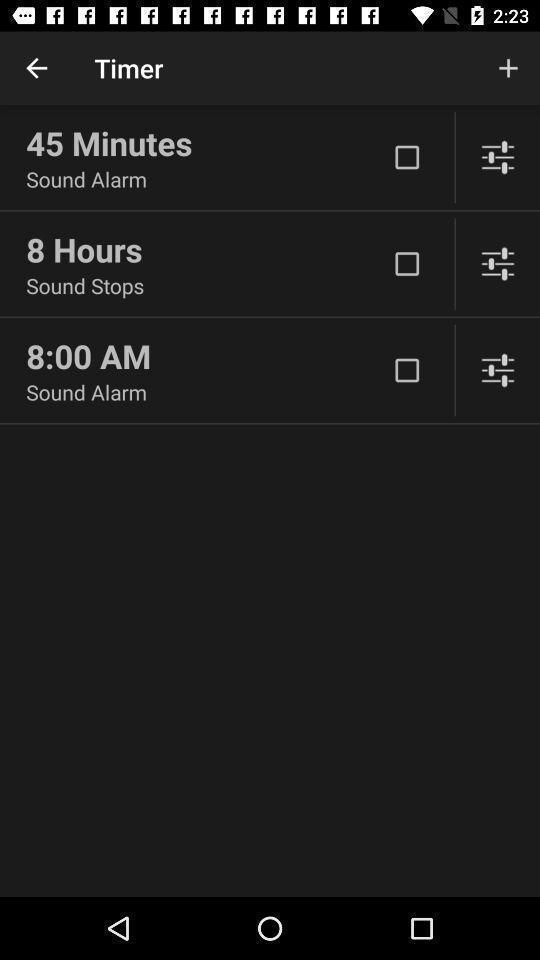Describe the content in this image. Screen displaying timer page with list of options to select. 